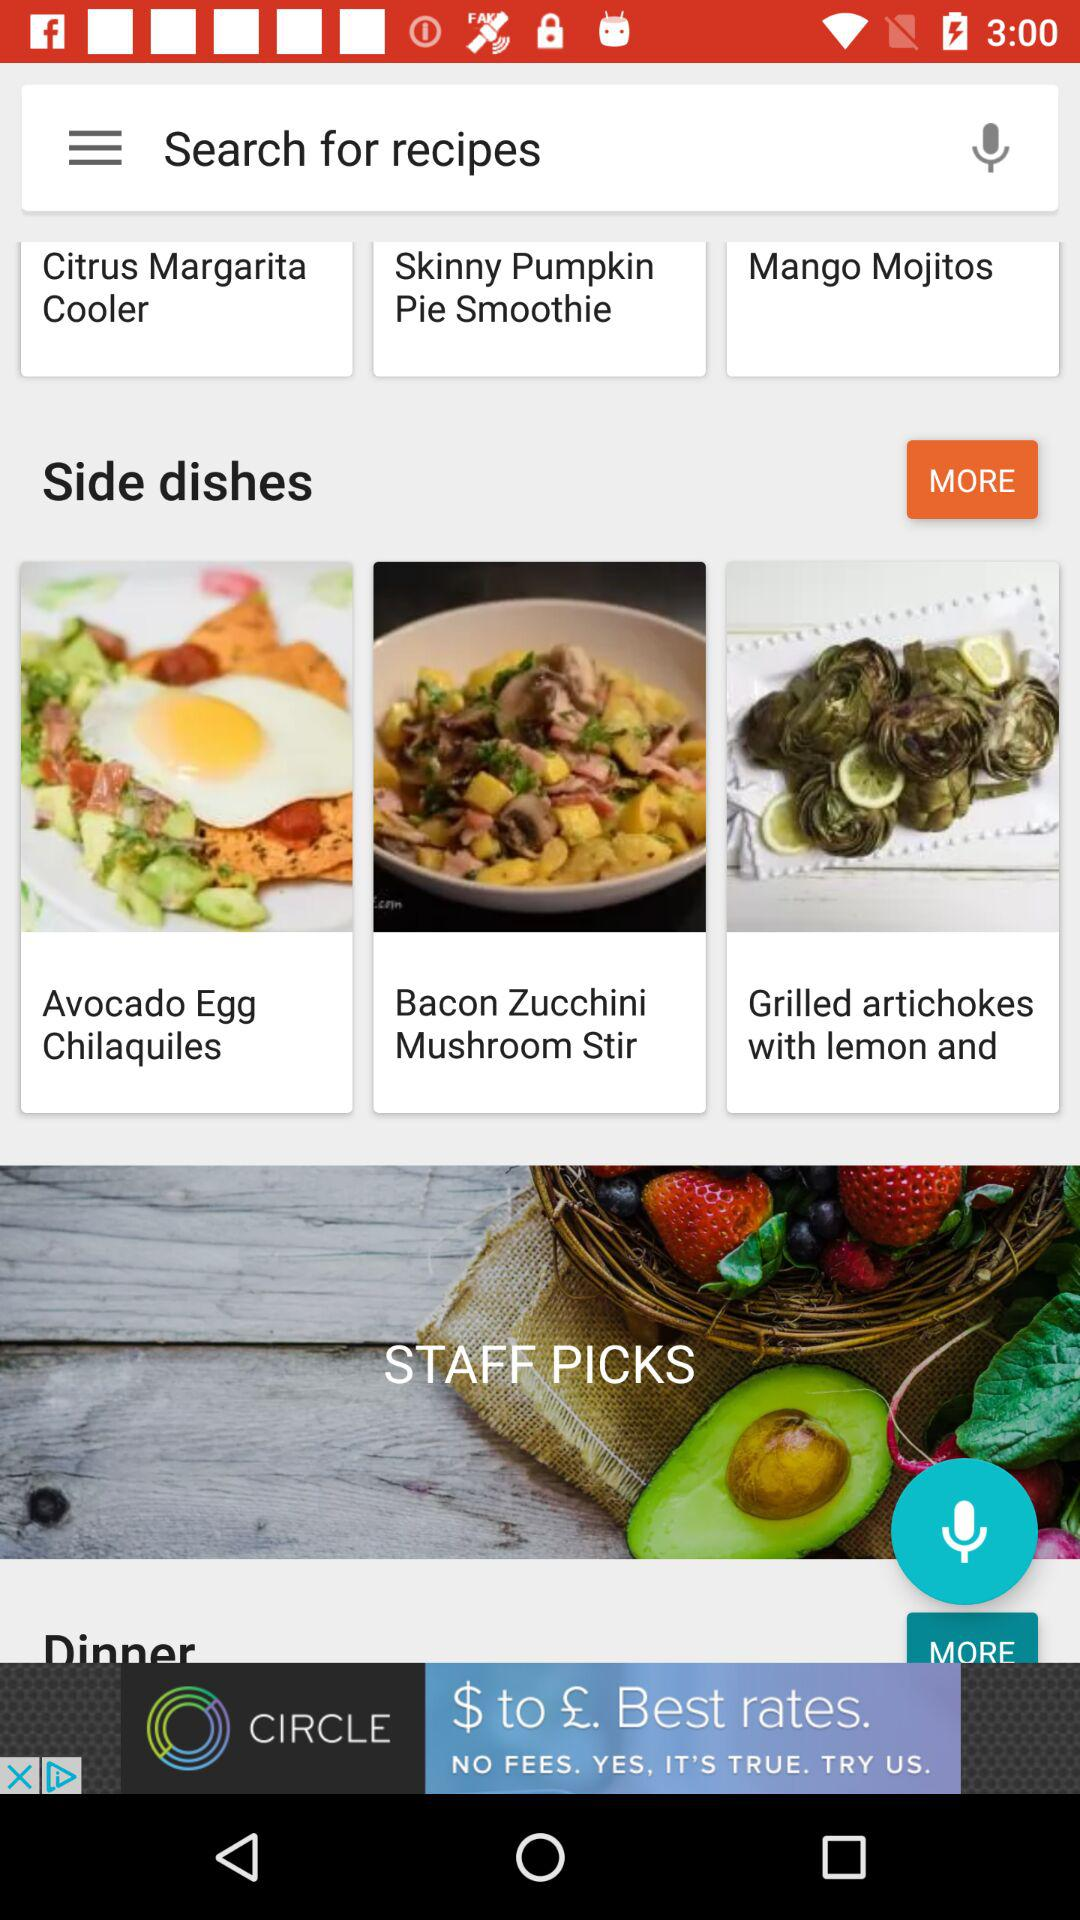What are the different available side dishes? The different available side dishes are "Avocado Egg Chilaquiles", "Bacon Zucchini Mushroom Stir" and "Grilled artichokes with lemon and". 